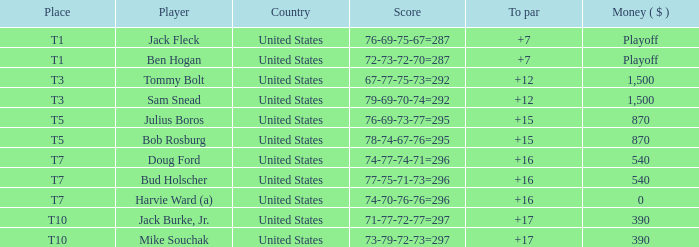As a player, what is bud holscher's average performance in relation to par? 16.0. 